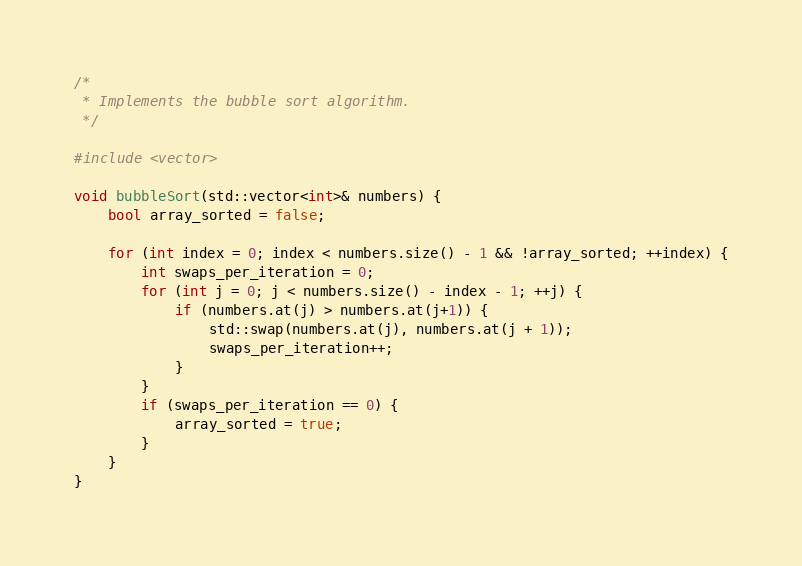<code> <loc_0><loc_0><loc_500><loc_500><_C++_>/*
 * Implements the bubble sort algorithm.
 */

#include <vector>

void bubbleSort(std::vector<int>& numbers) {
    bool array_sorted = false;

    for (int index = 0; index < numbers.size() - 1 && !array_sorted; ++index) {
        int swaps_per_iteration = 0;
        for (int j = 0; j < numbers.size() - index - 1; ++j) {
            if (numbers.at(j) > numbers.at(j+1)) {
                std::swap(numbers.at(j), numbers.at(j + 1));
                swaps_per_iteration++;
            }
        }
        if (swaps_per_iteration == 0) {
            array_sorted = true;
        }
    }
}</code> 